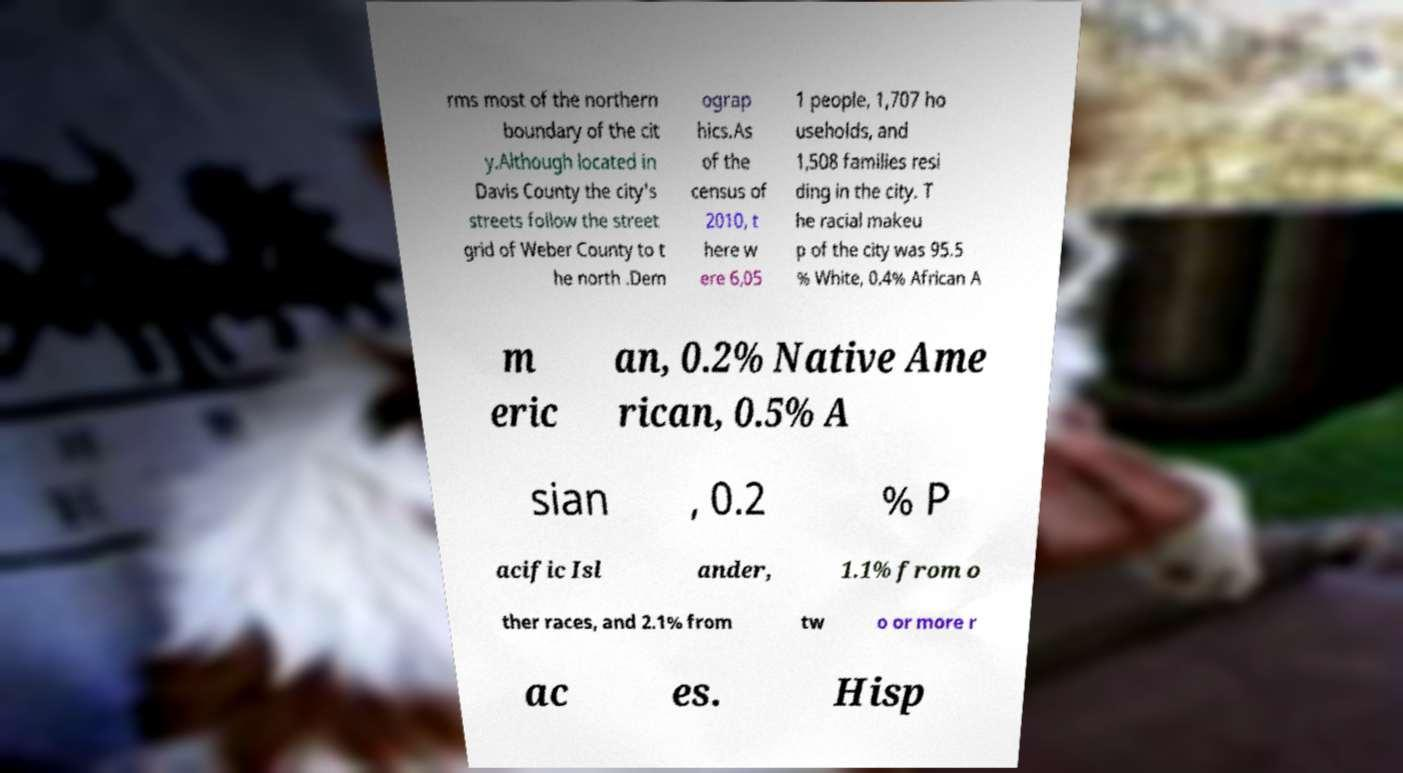Please identify and transcribe the text found in this image. rms most of the northern boundary of the cit y.Although located in Davis County the city's streets follow the street grid of Weber County to t he north .Dem ograp hics.As of the census of 2010, t here w ere 6,05 1 people, 1,707 ho useholds, and 1,508 families resi ding in the city. T he racial makeu p of the city was 95.5 % White, 0.4% African A m eric an, 0.2% Native Ame rican, 0.5% A sian , 0.2 % P acific Isl ander, 1.1% from o ther races, and 2.1% from tw o or more r ac es. Hisp 